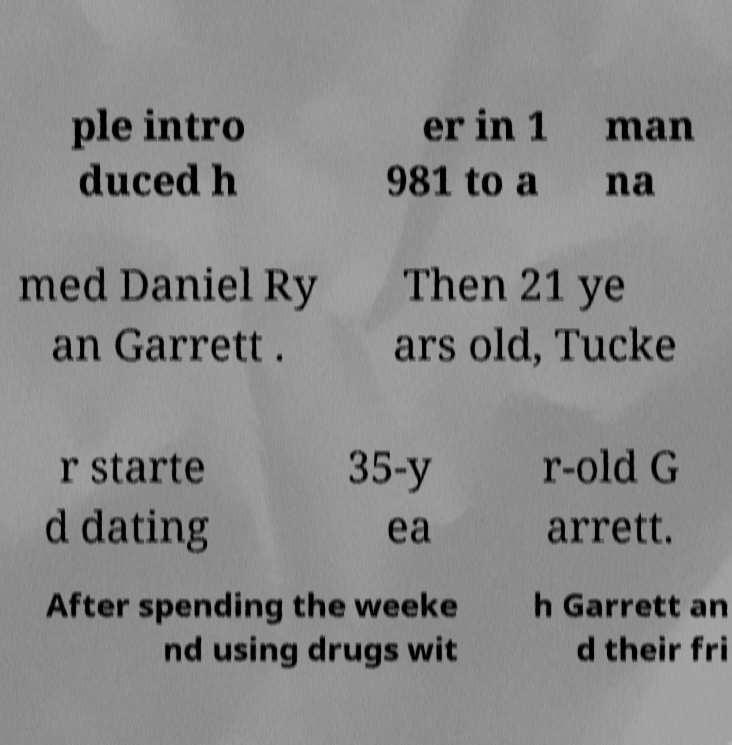Can you accurately transcribe the text from the provided image for me? ple intro duced h er in 1 981 to a man na med Daniel Ry an Garrett . Then 21 ye ars old, Tucke r starte d dating 35-y ea r-old G arrett. After spending the weeke nd using drugs wit h Garrett an d their fri 